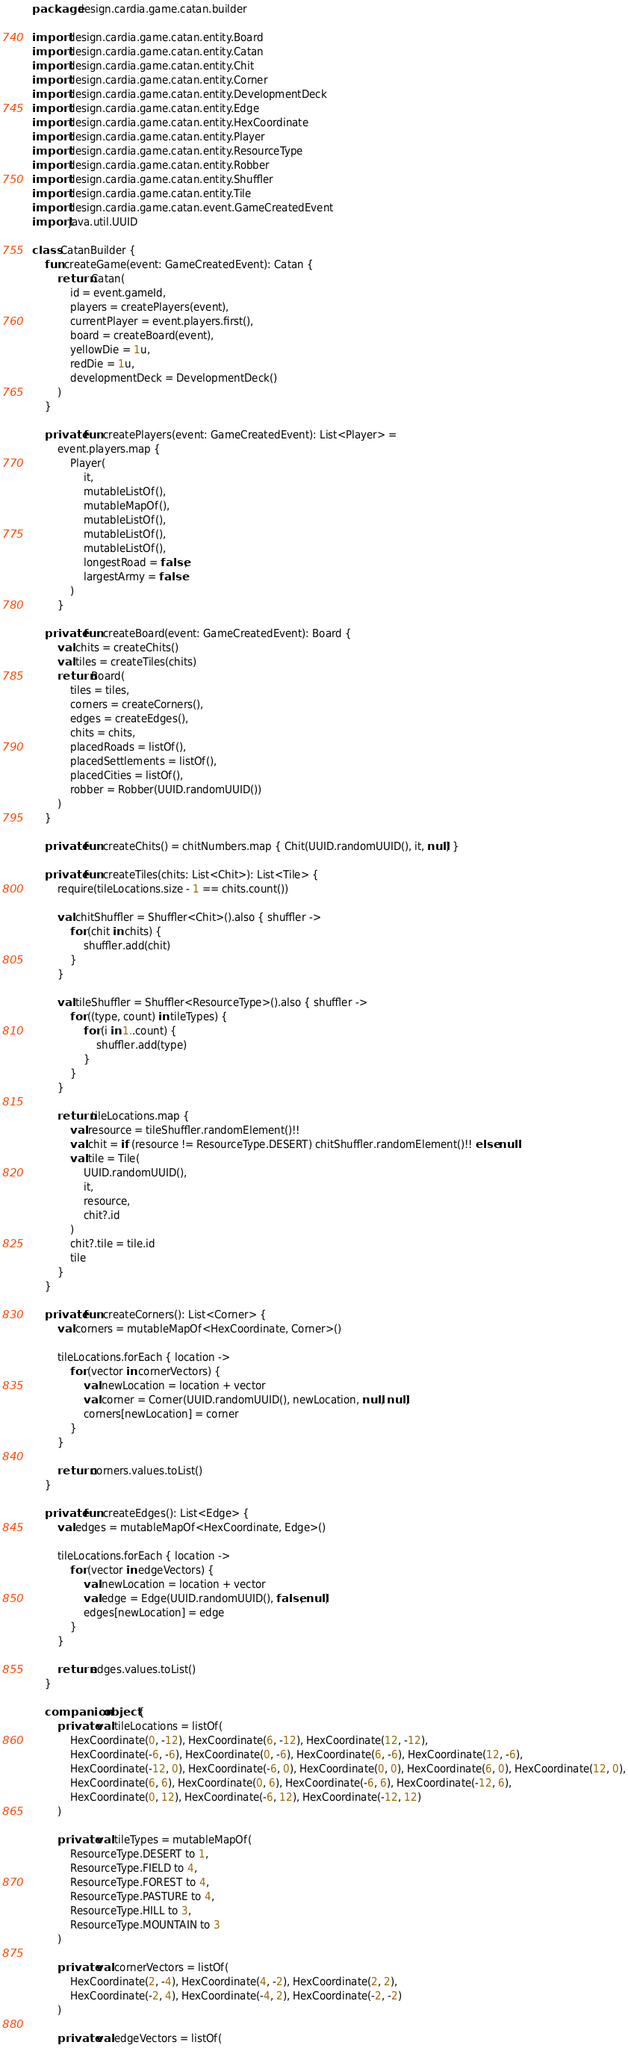Convert code to text. <code><loc_0><loc_0><loc_500><loc_500><_Kotlin_>package design.cardia.game.catan.builder

import design.cardia.game.catan.entity.Board
import design.cardia.game.catan.entity.Catan
import design.cardia.game.catan.entity.Chit
import design.cardia.game.catan.entity.Corner
import design.cardia.game.catan.entity.DevelopmentDeck
import design.cardia.game.catan.entity.Edge
import design.cardia.game.catan.entity.HexCoordinate
import design.cardia.game.catan.entity.Player
import design.cardia.game.catan.entity.ResourceType
import design.cardia.game.catan.entity.Robber
import design.cardia.game.catan.entity.Shuffler
import design.cardia.game.catan.entity.Tile
import design.cardia.game.catan.event.GameCreatedEvent
import java.util.UUID

class CatanBuilder {
    fun createGame(event: GameCreatedEvent): Catan {
        return Catan(
            id = event.gameId,
            players = createPlayers(event),
            currentPlayer = event.players.first(),
            board = createBoard(event),
            yellowDie = 1u,
            redDie = 1u,
            developmentDeck = DevelopmentDeck()
        )
    }

    private fun createPlayers(event: GameCreatedEvent): List<Player> =
        event.players.map {
            Player(
                it,
                mutableListOf(),
                mutableMapOf(),
                mutableListOf(),
                mutableListOf(),
                mutableListOf(),
                longestRoad = false,
                largestArmy = false
            )
        }

    private fun createBoard(event: GameCreatedEvent): Board {
        val chits = createChits()
        val tiles = createTiles(chits)
        return Board(
            tiles = tiles,
            corners = createCorners(),
            edges = createEdges(),
            chits = chits,
            placedRoads = listOf(),
            placedSettlements = listOf(),
            placedCities = listOf(),
            robber = Robber(UUID.randomUUID())
        )
    }

    private fun createChits() = chitNumbers.map { Chit(UUID.randomUUID(), it, null) }

    private fun createTiles(chits: List<Chit>): List<Tile> {
        require(tileLocations.size - 1 == chits.count())

        val chitShuffler = Shuffler<Chit>().also { shuffler ->
            for (chit in chits) {
                shuffler.add(chit)
            }
        }

        val tileShuffler = Shuffler<ResourceType>().also { shuffler ->
            for ((type, count) in tileTypes) {
                for (i in 1..count) {
                    shuffler.add(type)
                }
            }
        }

        return tileLocations.map {
            val resource = tileShuffler.randomElement()!!
            val chit = if (resource != ResourceType.DESERT) chitShuffler.randomElement()!! else null
            val tile = Tile(
                UUID.randomUUID(),
                it,
                resource,
                chit?.id
            )
            chit?.tile = tile.id
            tile
        }
    }

    private fun createCorners(): List<Corner> {
        val corners = mutableMapOf<HexCoordinate, Corner>()

        tileLocations.forEach { location ->
            for (vector in cornerVectors) {
                val newLocation = location + vector
                val corner = Corner(UUID.randomUUID(), newLocation, null, null)
                corners[newLocation] = corner
            }
        }

        return corners.values.toList()
    }

    private fun createEdges(): List<Edge> {
        val edges = mutableMapOf<HexCoordinate, Edge>()

        tileLocations.forEach { location ->
            for (vector in edgeVectors) {
                val newLocation = location + vector
                val edge = Edge(UUID.randomUUID(), false, null)
                edges[newLocation] = edge
            }
        }

        return edges.values.toList()
    }

    companion object {
        private val tileLocations = listOf(
            HexCoordinate(0, -12), HexCoordinate(6, -12), HexCoordinate(12, -12),
            HexCoordinate(-6, -6), HexCoordinate(0, -6), HexCoordinate(6, -6), HexCoordinate(12, -6),
            HexCoordinate(-12, 0), HexCoordinate(-6, 0), HexCoordinate(0, 0), HexCoordinate(6, 0), HexCoordinate(12, 0),
            HexCoordinate(6, 6), HexCoordinate(0, 6), HexCoordinate(-6, 6), HexCoordinate(-12, 6),
            HexCoordinate(0, 12), HexCoordinate(-6, 12), HexCoordinate(-12, 12)
        )

        private val tileTypes = mutableMapOf(
            ResourceType.DESERT to 1,
            ResourceType.FIELD to 4,
            ResourceType.FOREST to 4,
            ResourceType.PASTURE to 4,
            ResourceType.HILL to 3,
            ResourceType.MOUNTAIN to 3
        )

        private val cornerVectors = listOf(
            HexCoordinate(2, -4), HexCoordinate(4, -2), HexCoordinate(2, 2),
            HexCoordinate(-2, 4), HexCoordinate(-4, 2), HexCoordinate(-2, -2)
        )

        private val edgeVectors = listOf(</code> 